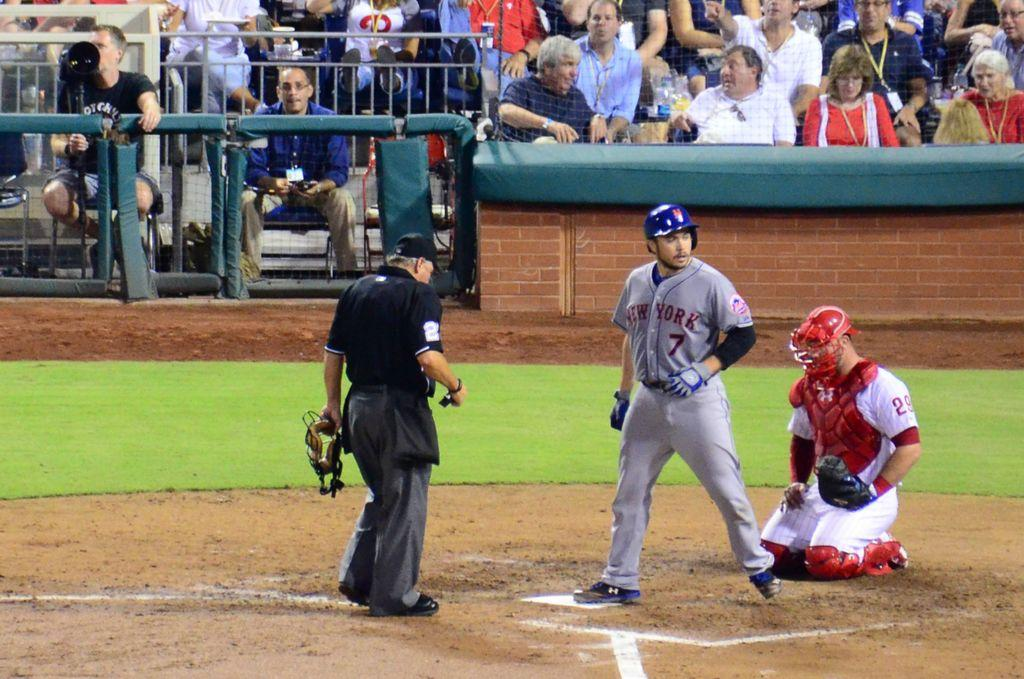How many people are in the foreground of the image? There are three persons in the foreground of the image. What are the three persons doing in the image? The three persons are on the ground. What can be seen in the background of the image? There is a fence, a wall, and a crowd in a stadium in the background of the image. What type of yam is being weighed in the image? There is no yam present in the image, and therefore no such activity can be observed. 